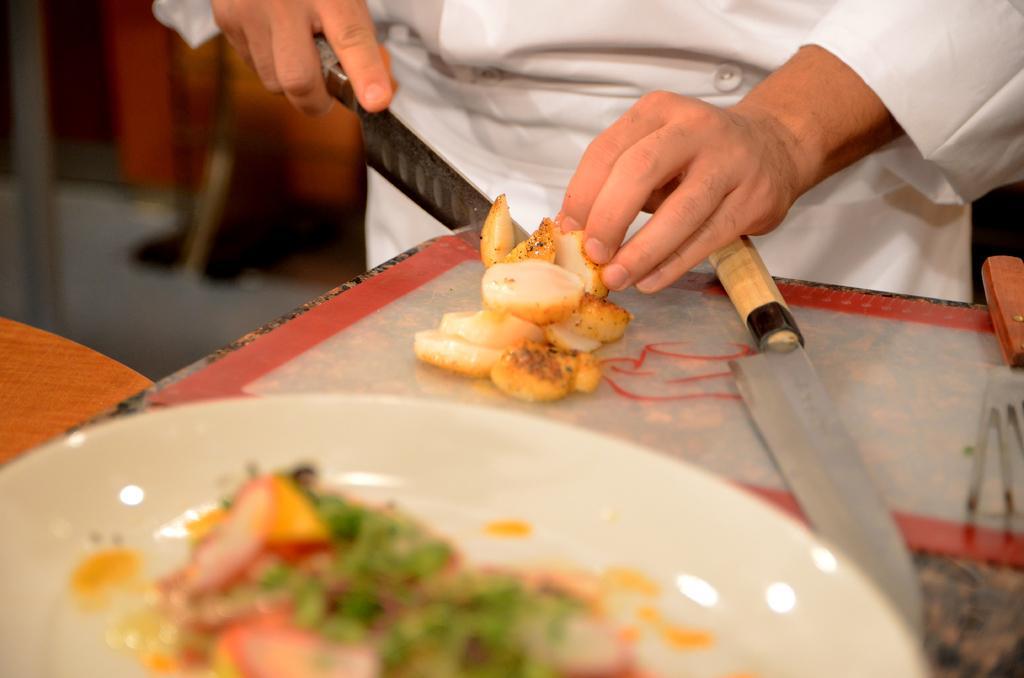Describe this image in one or two sentences. In this image, we can see a person standing and holding a knife. We can see some food on the plate. 